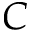Convert formula to latex. <formula><loc_0><loc_0><loc_500><loc_500>C</formula> 